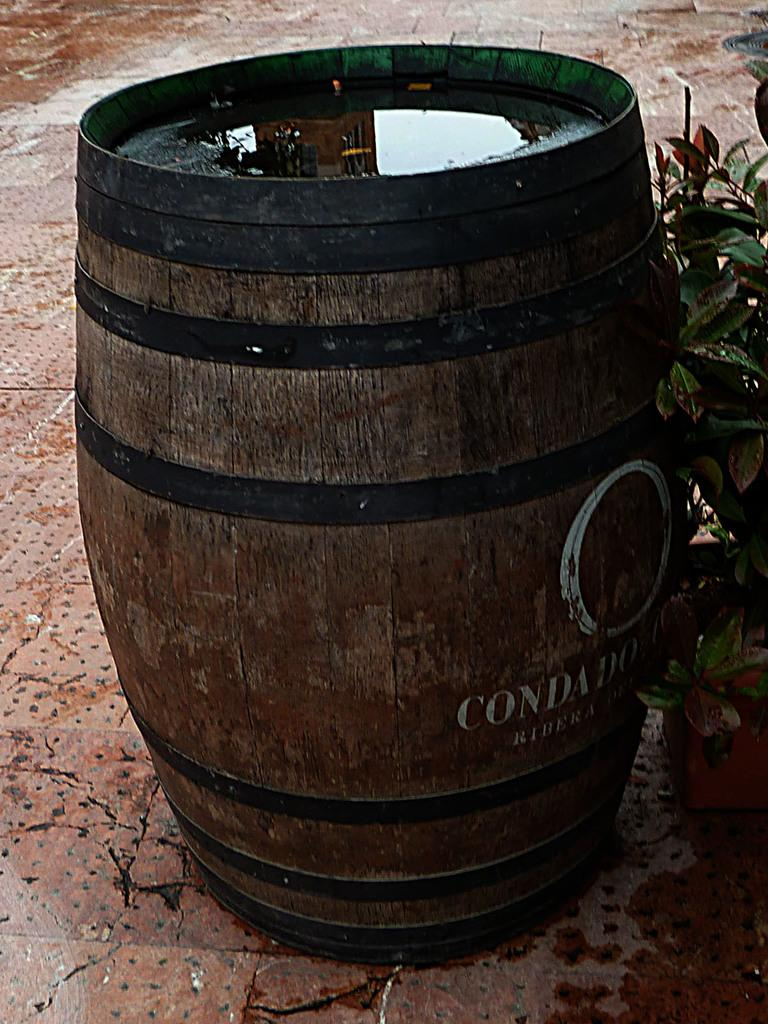<image>
Share a concise interpretation of the image provided. An old looking batter with the words Condado written in the middle 